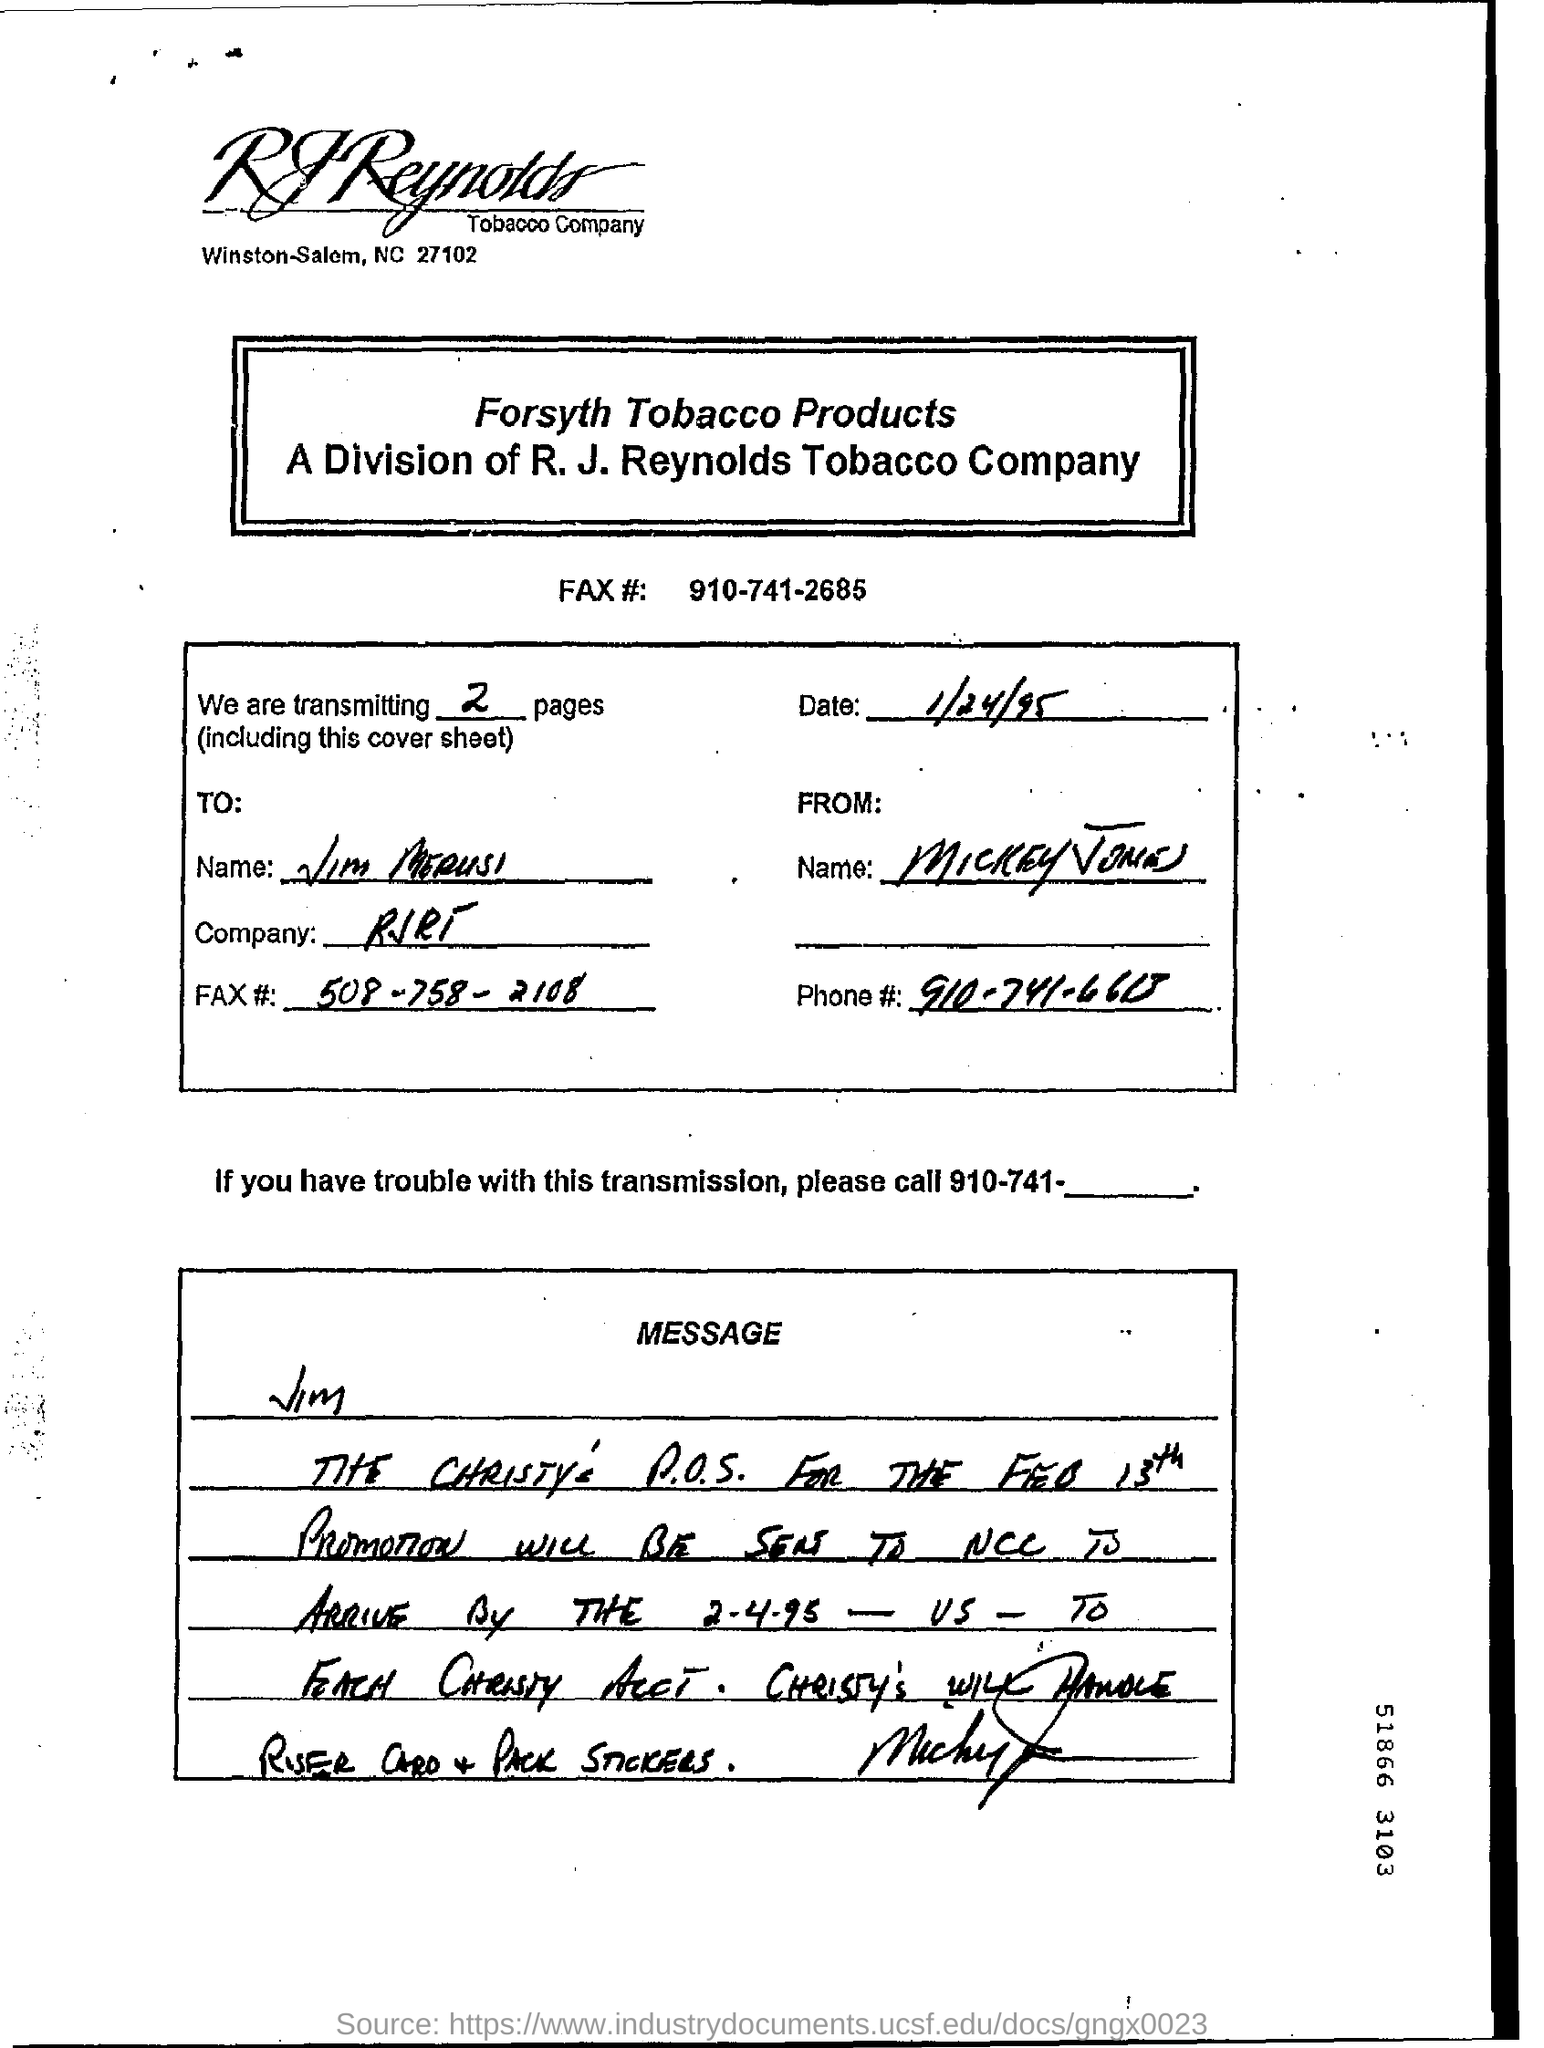Draw attention to some important aspects in this diagram. The exact number of pages being transmitted is unknown. 